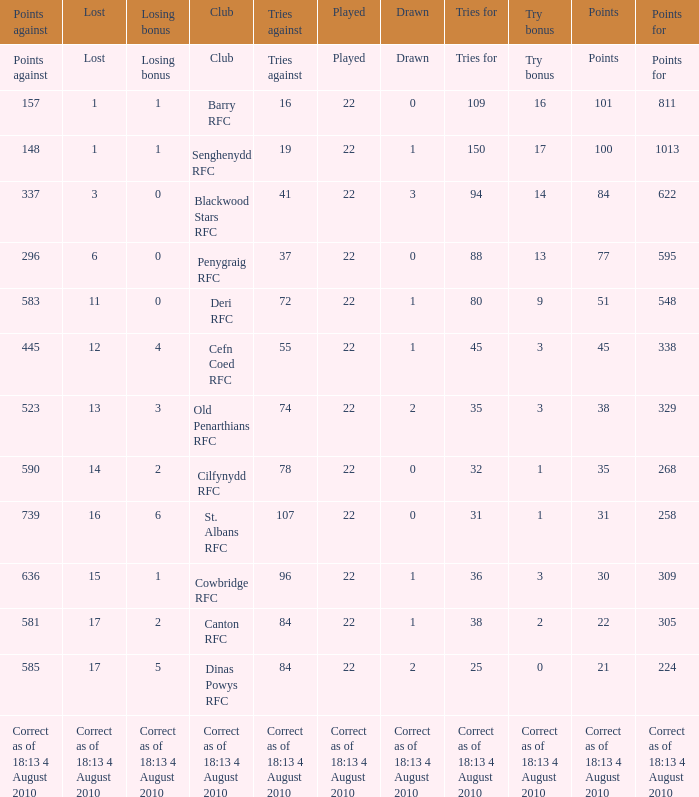What is the name of the club with 22 points? Canton RFC. 